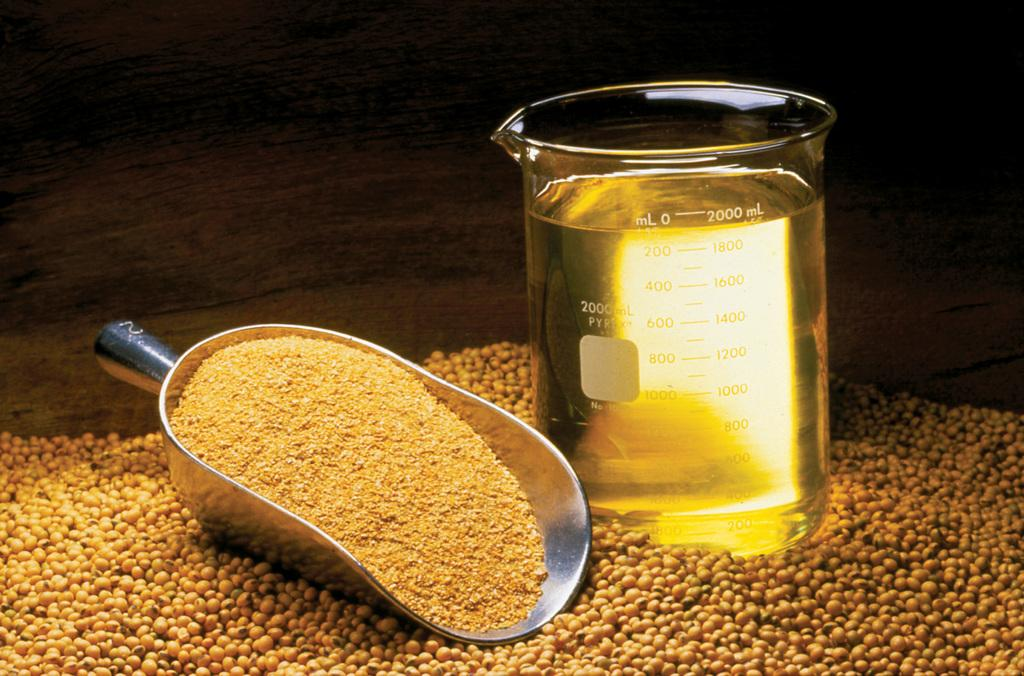<image>
Relay a brief, clear account of the picture shown. A scoop of grain is next to a Pyrex measuring cup showing a little less than 2000 ml of liquid. 